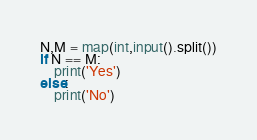<code> <loc_0><loc_0><loc_500><loc_500><_Python_>N,M = map(int,input().split())
if N == M:
    print('Yes')
else:
    print('No')</code> 